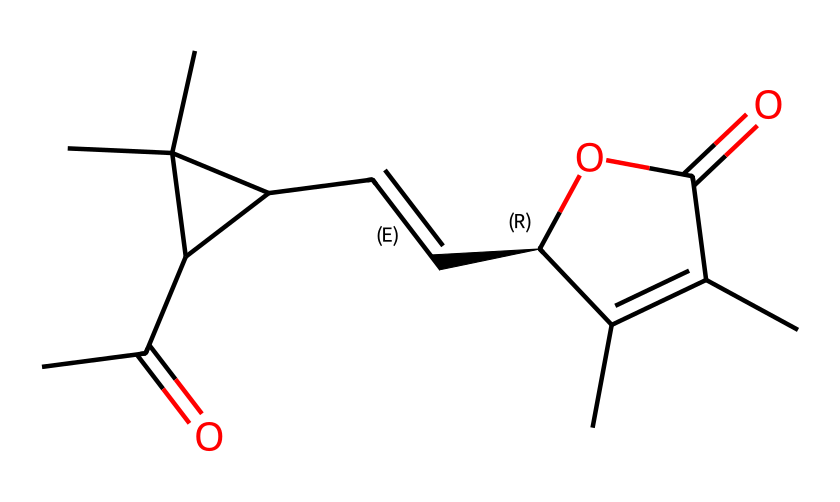What is the molecular formula of pyrethrin? By analyzing the provided SMILES representation, we can identify the number of each type of atom present in the molecule. Counting the carbon (C), hydrogen (H), and oxygen (O) atoms yields the molecular formula C21H28O5.
Answer: C21H28O5 How many rings are present in the pyrethrin structure? Upon examining the structure, we notice there are two cyclical components when visualizing the molecule: one five-membered ring and another six-membered ring, resulting in a total of two rings in the molecule.
Answer: 2 What type of chemical compound is pyrethrin classified as? Looking at the structure and considering its natural origin from chrysanthemum flowers, we classify pyrethrin as a natural pesticide, specifically an insecticide. This classification is based on its biological activity rather than solely its chemical structure.
Answer: insecticide How many ester functional groups are present in pyrethrin? In the SMILES representation, we identify the presence of functional groups and count them. The presence of a carboxyl (-COOH) and oxy groups (-O-) indicates there are two ester functional groups in the structure.
Answer: 2 What is the role of the oxygen atoms in pyrethrin's molecular structure? The oxygen atoms in pyrethrin primarily serve as part of functional groups involved in its chemical stability and bioactivity. Specifically, they participate in creating ester bonds and influence the overall solubility and reactivity of the molecule.
Answer: bioactivity 